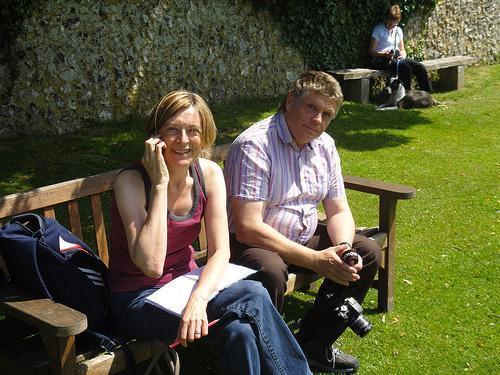How many dogs are in the park?
Give a very brief answer. 1. 